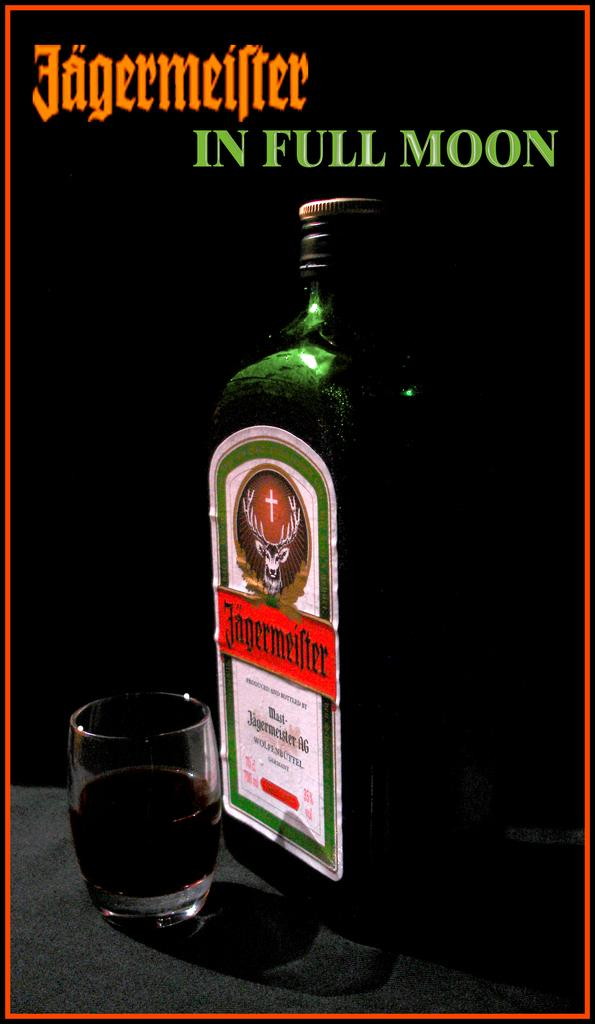<image>
Share a concise interpretation of the image provided. A bottom of Jagermeifter sits next to a drinking glass that is half full 